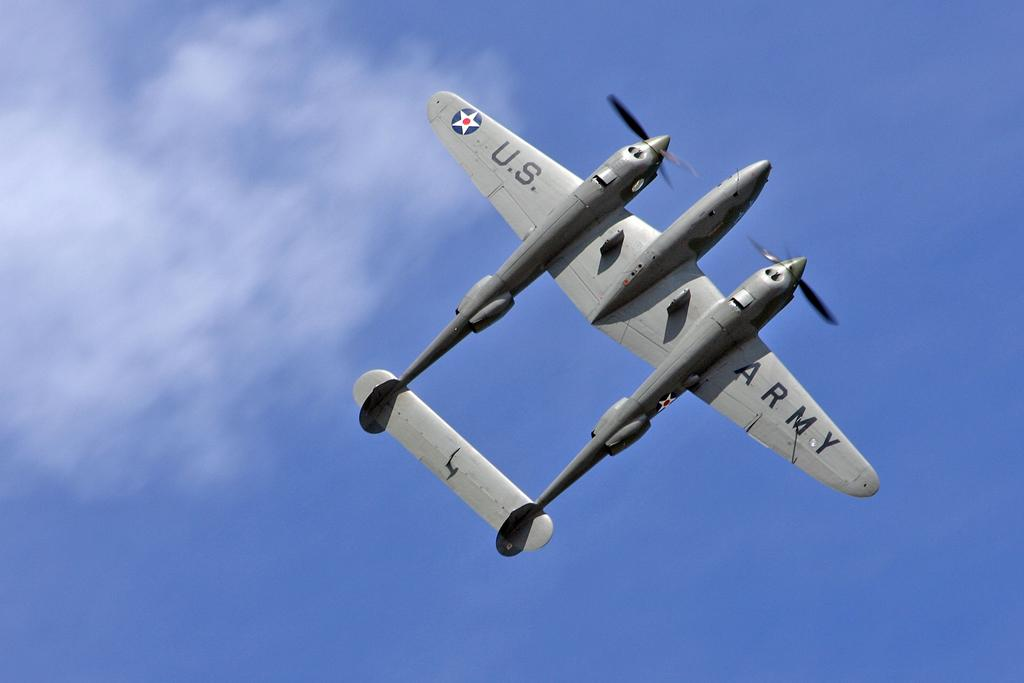What is the main subject of the image? There is an aircraft in the image. What color is the aircraft? The aircraft is gray in color. What is the aircraft doing in the image? The aircraft is flying in the air. What can be seen in the background of the image? There are clouds in the background of the image. What is the color of the sky in the image? The sky is blue in the image. What type of cloth is being used to play basketball in the image? There is no cloth or basketball present in the image; it features an aircraft flying in the sky with clouds and a blue sky. 